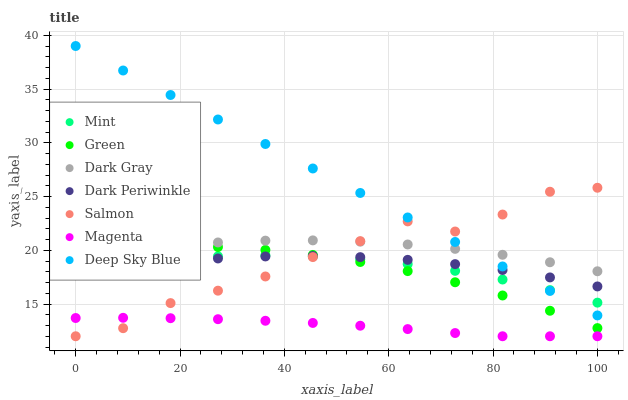Does Magenta have the minimum area under the curve?
Answer yes or no. Yes. Does Deep Sky Blue have the maximum area under the curve?
Answer yes or no. Yes. Does Dark Gray have the minimum area under the curve?
Answer yes or no. No. Does Dark Gray have the maximum area under the curve?
Answer yes or no. No. Is Deep Sky Blue the smoothest?
Answer yes or no. Yes. Is Salmon the roughest?
Answer yes or no. Yes. Is Dark Gray the smoothest?
Answer yes or no. No. Is Dark Gray the roughest?
Answer yes or no. No. Does Salmon have the lowest value?
Answer yes or no. Yes. Does Green have the lowest value?
Answer yes or no. No. Does Deep Sky Blue have the highest value?
Answer yes or no. Yes. Does Dark Gray have the highest value?
Answer yes or no. No. Is Magenta less than Deep Sky Blue?
Answer yes or no. Yes. Is Deep Sky Blue greater than Magenta?
Answer yes or no. Yes. Does Dark Periwinkle intersect Deep Sky Blue?
Answer yes or no. Yes. Is Dark Periwinkle less than Deep Sky Blue?
Answer yes or no. No. Is Dark Periwinkle greater than Deep Sky Blue?
Answer yes or no. No. Does Magenta intersect Deep Sky Blue?
Answer yes or no. No. 